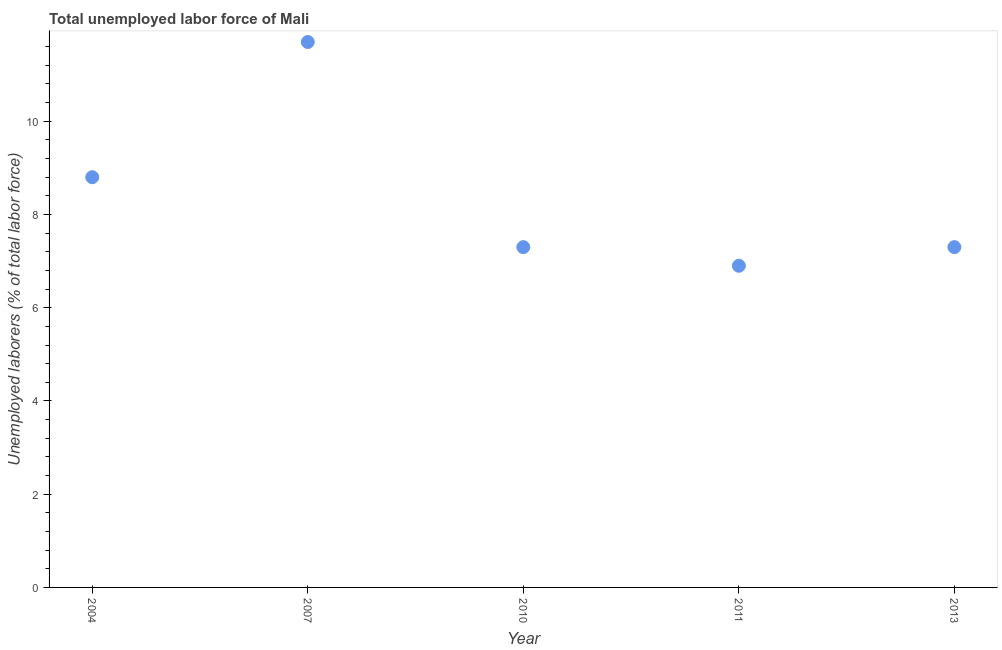What is the total unemployed labour force in 2010?
Your answer should be very brief. 7.3. Across all years, what is the maximum total unemployed labour force?
Keep it short and to the point. 11.7. Across all years, what is the minimum total unemployed labour force?
Give a very brief answer. 6.9. What is the sum of the total unemployed labour force?
Provide a succinct answer. 42. What is the difference between the total unemployed labour force in 2007 and 2010?
Provide a short and direct response. 4.4. What is the average total unemployed labour force per year?
Ensure brevity in your answer.  8.4. What is the median total unemployed labour force?
Provide a short and direct response. 7.3. In how many years, is the total unemployed labour force greater than 2 %?
Make the answer very short. 5. Do a majority of the years between 2007 and 2010 (inclusive) have total unemployed labour force greater than 6.8 %?
Your answer should be compact. Yes. What is the ratio of the total unemployed labour force in 2007 to that in 2011?
Your answer should be very brief. 1.7. Is the difference between the total unemployed labour force in 2007 and 2010 greater than the difference between any two years?
Provide a short and direct response. No. What is the difference between the highest and the second highest total unemployed labour force?
Ensure brevity in your answer.  2.9. Is the sum of the total unemployed labour force in 2010 and 2011 greater than the maximum total unemployed labour force across all years?
Ensure brevity in your answer.  Yes. What is the difference between the highest and the lowest total unemployed labour force?
Offer a terse response. 4.8. In how many years, is the total unemployed labour force greater than the average total unemployed labour force taken over all years?
Keep it short and to the point. 2. Does the total unemployed labour force monotonically increase over the years?
Provide a short and direct response. No. How many dotlines are there?
Provide a succinct answer. 1. What is the title of the graph?
Offer a terse response. Total unemployed labor force of Mali. What is the label or title of the Y-axis?
Ensure brevity in your answer.  Unemployed laborers (% of total labor force). What is the Unemployed laborers (% of total labor force) in 2004?
Provide a short and direct response. 8.8. What is the Unemployed laborers (% of total labor force) in 2007?
Ensure brevity in your answer.  11.7. What is the Unemployed laborers (% of total labor force) in 2010?
Offer a very short reply. 7.3. What is the Unemployed laborers (% of total labor force) in 2011?
Ensure brevity in your answer.  6.9. What is the Unemployed laborers (% of total labor force) in 2013?
Offer a very short reply. 7.3. What is the difference between the Unemployed laborers (% of total labor force) in 2004 and 2007?
Offer a very short reply. -2.9. What is the difference between the Unemployed laborers (% of total labor force) in 2004 and 2013?
Your answer should be compact. 1.5. What is the difference between the Unemployed laborers (% of total labor force) in 2007 and 2011?
Provide a short and direct response. 4.8. What is the difference between the Unemployed laborers (% of total labor force) in 2007 and 2013?
Provide a succinct answer. 4.4. What is the difference between the Unemployed laborers (% of total labor force) in 2010 and 2011?
Your answer should be very brief. 0.4. What is the ratio of the Unemployed laborers (% of total labor force) in 2004 to that in 2007?
Offer a very short reply. 0.75. What is the ratio of the Unemployed laborers (% of total labor force) in 2004 to that in 2010?
Keep it short and to the point. 1.21. What is the ratio of the Unemployed laborers (% of total labor force) in 2004 to that in 2011?
Provide a succinct answer. 1.27. What is the ratio of the Unemployed laborers (% of total labor force) in 2004 to that in 2013?
Give a very brief answer. 1.21. What is the ratio of the Unemployed laborers (% of total labor force) in 2007 to that in 2010?
Keep it short and to the point. 1.6. What is the ratio of the Unemployed laborers (% of total labor force) in 2007 to that in 2011?
Offer a terse response. 1.7. What is the ratio of the Unemployed laborers (% of total labor force) in 2007 to that in 2013?
Offer a very short reply. 1.6. What is the ratio of the Unemployed laborers (% of total labor force) in 2010 to that in 2011?
Offer a terse response. 1.06. What is the ratio of the Unemployed laborers (% of total labor force) in 2011 to that in 2013?
Your answer should be very brief. 0.94. 